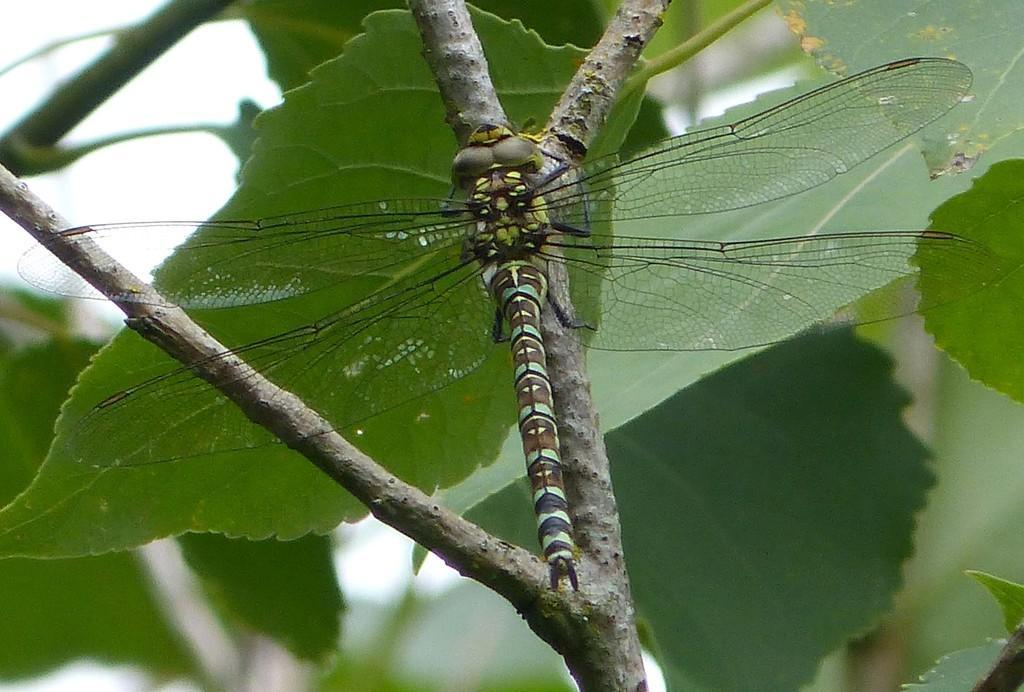In one or two sentences, can you explain what this image depicts? In this image we can see a dragonfly on the stem of a plant. In the background there are leaves and sky. 